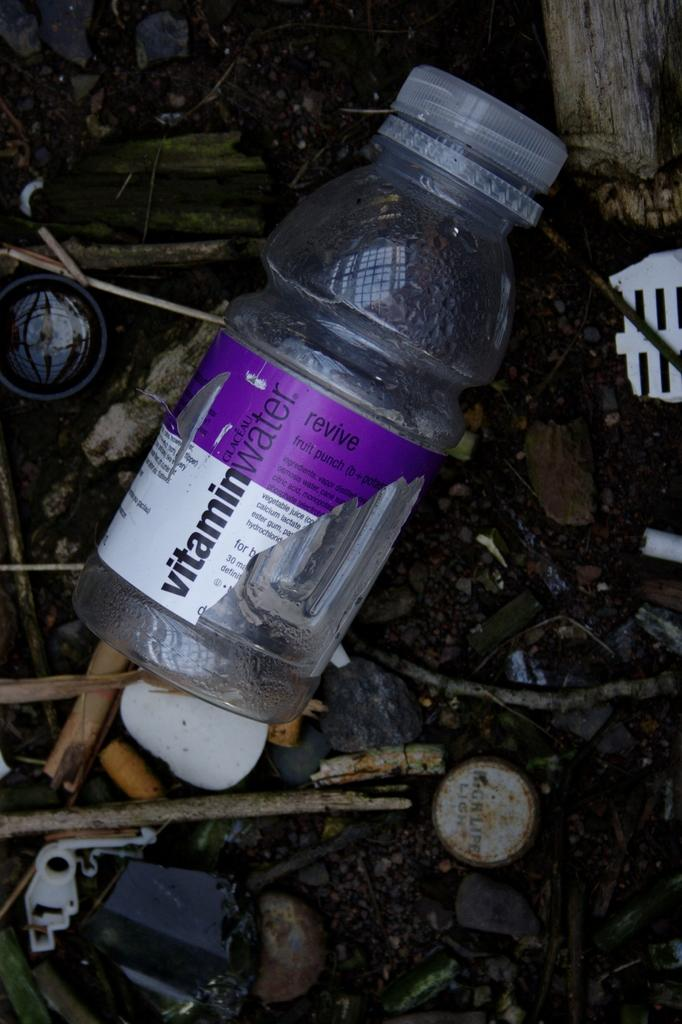What object can be seen lying on the ground in the image? There is a bottle lying on the ground in the image. What feature does the bottle have? The bottle has a cap. What other objects can be seen in the image besides the bottle? There are sticks, stones, and wooden items in the image. What type of amusement can be seen in the image? There is no amusement present in the image; it features a bottle, sticks, stones, and wooden items. Is there a spy observing the scene in the image? There is no indication of a spy or any person in the image; it only shows objects. 